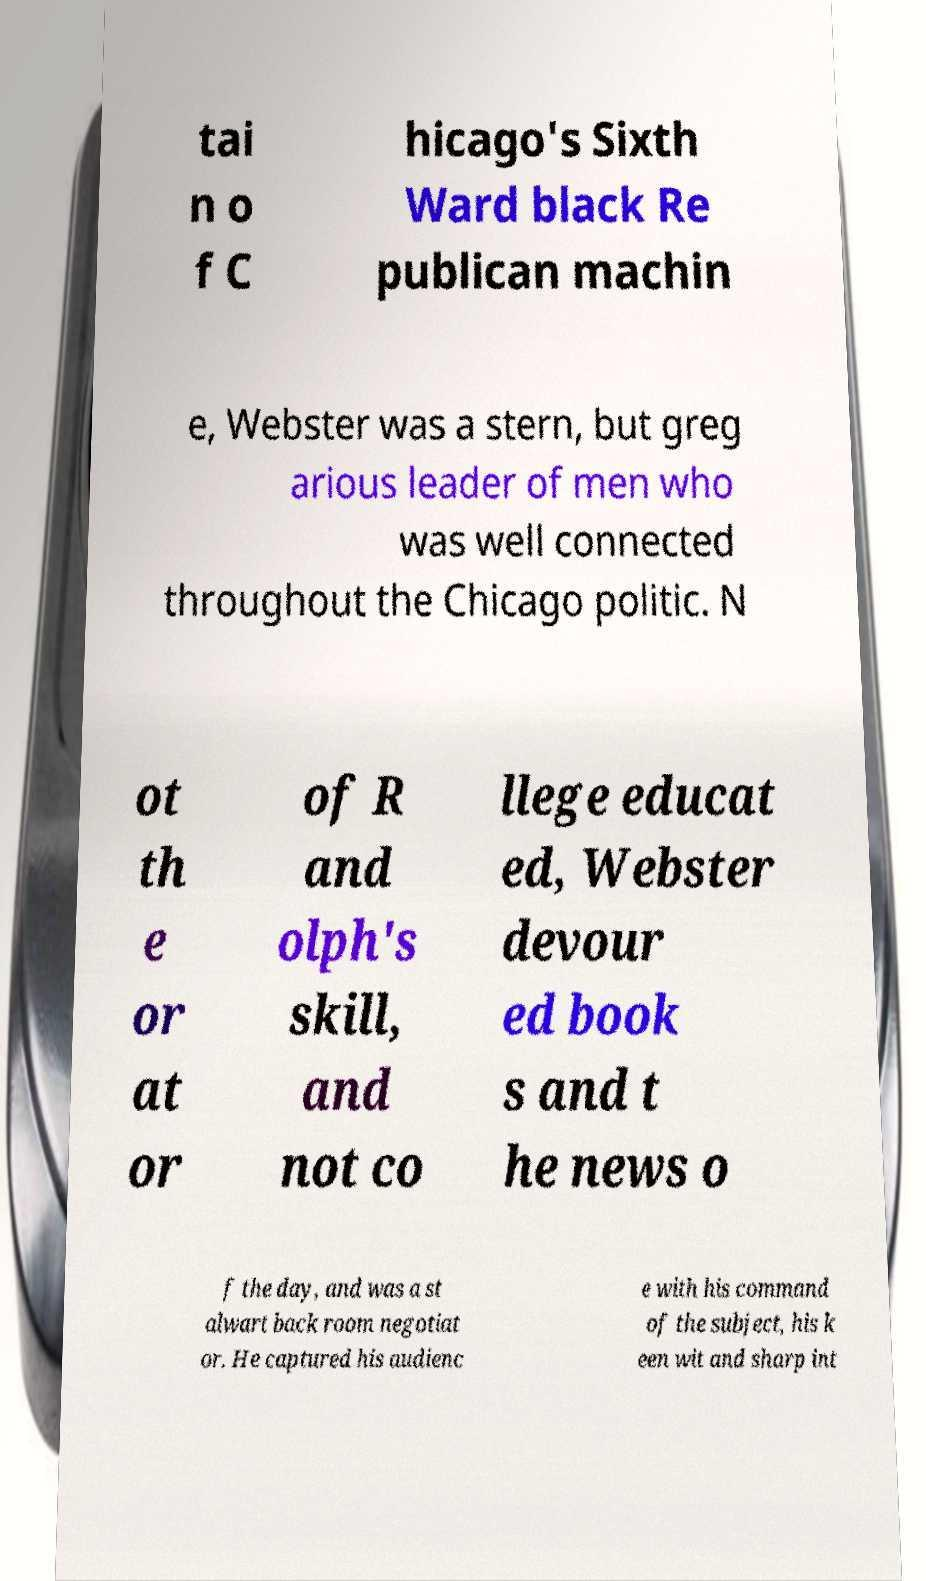What messages or text are displayed in this image? I need them in a readable, typed format. tai n o f C hicago's Sixth Ward black Re publican machin e, Webster was a stern, but greg arious leader of men who was well connected throughout the Chicago politic. N ot th e or at or of R and olph's skill, and not co llege educat ed, Webster devour ed book s and t he news o f the day, and was a st alwart back room negotiat or. He captured his audienc e with his command of the subject, his k een wit and sharp int 